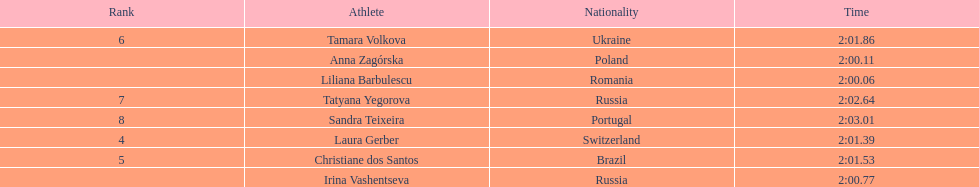What is the name of the top finalist of this semifinals heat? Liliana Barbulescu. 